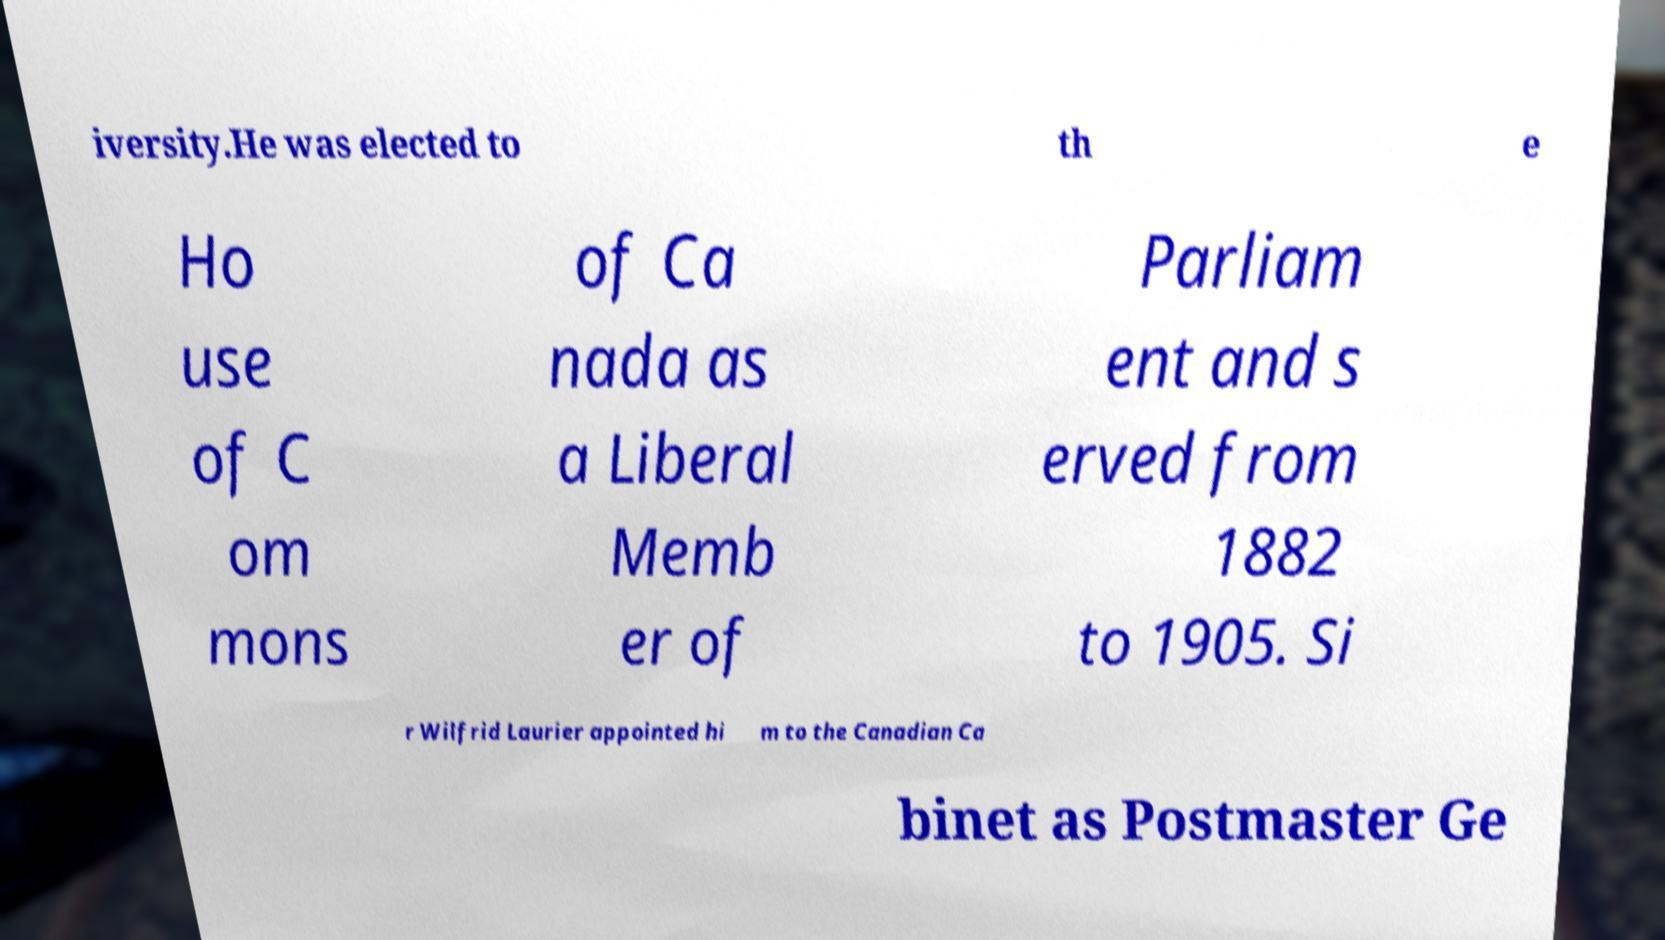For documentation purposes, I need the text within this image transcribed. Could you provide that? iversity.He was elected to th e Ho use of C om mons of Ca nada as a Liberal Memb er of Parliam ent and s erved from 1882 to 1905. Si r Wilfrid Laurier appointed hi m to the Canadian Ca binet as Postmaster Ge 